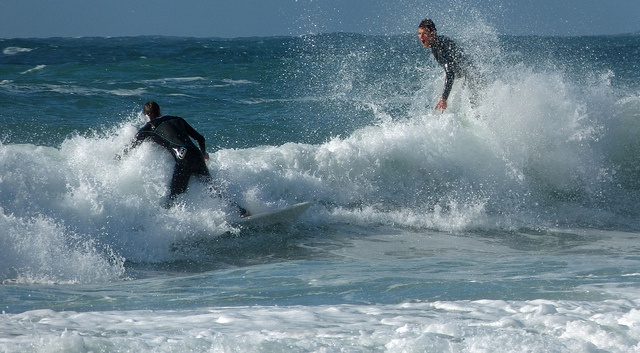Describe the objects in this image and their specific colors. I can see people in gray, black, blue, and darkgray tones, surfboard in gray, darkgray, and lightgray tones, people in gray, black, darkgray, and purple tones, and surfboard in gray, purple, blue, black, and darkblue tones in this image. 